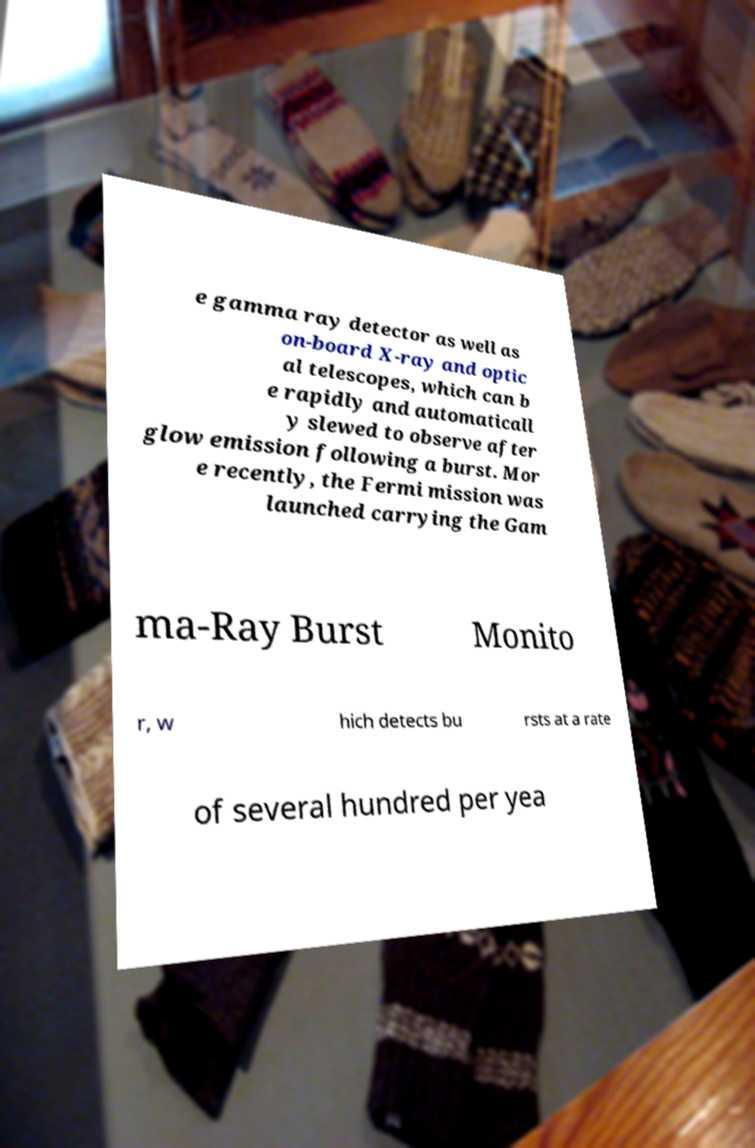Can you read and provide the text displayed in the image?This photo seems to have some interesting text. Can you extract and type it out for me? e gamma ray detector as well as on-board X-ray and optic al telescopes, which can b e rapidly and automaticall y slewed to observe after glow emission following a burst. Mor e recently, the Fermi mission was launched carrying the Gam ma-Ray Burst Monito r, w hich detects bu rsts at a rate of several hundred per yea 